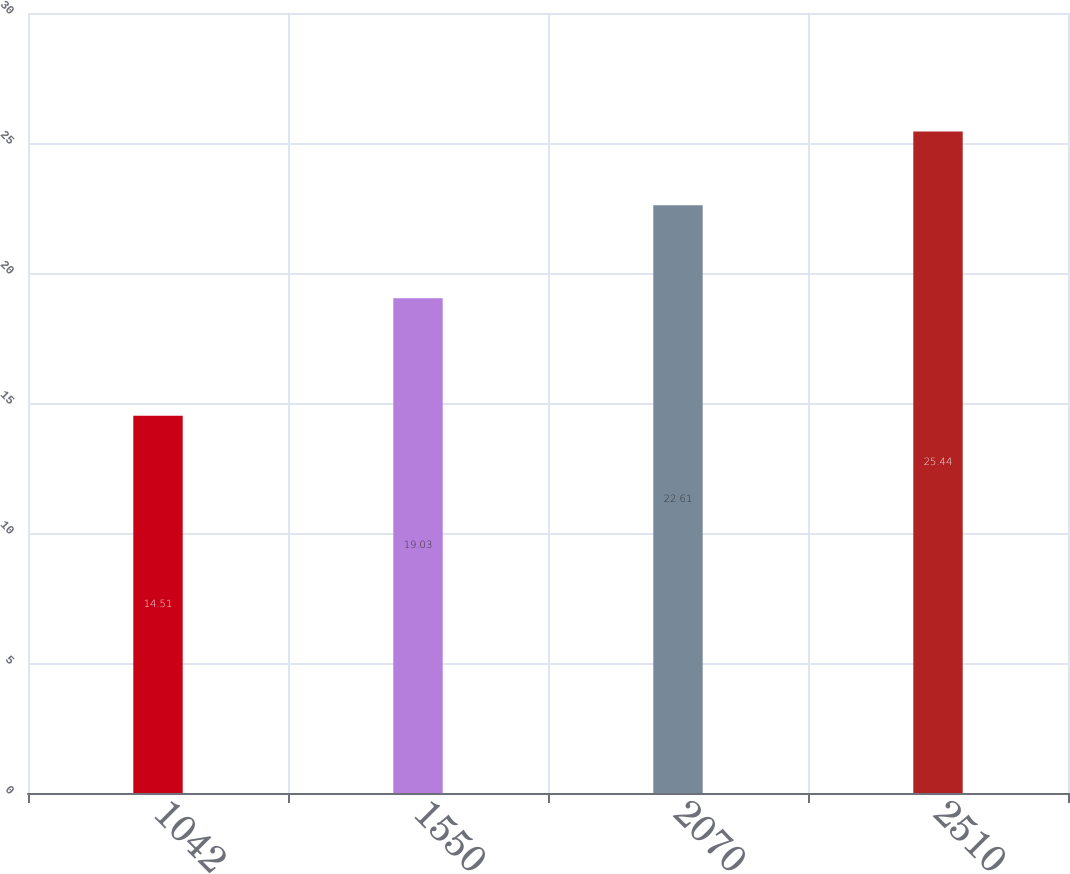<chart> <loc_0><loc_0><loc_500><loc_500><bar_chart><fcel>1042<fcel>1550<fcel>2070<fcel>2510<nl><fcel>14.51<fcel>19.03<fcel>22.61<fcel>25.44<nl></chart> 